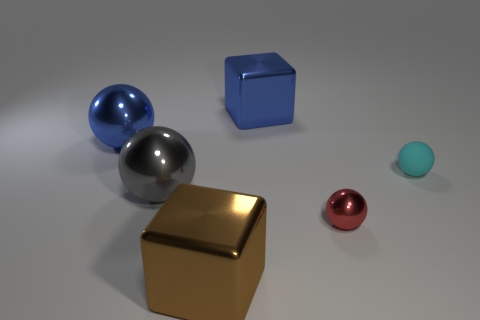Subtract all red balls. How many balls are left? 3 Subtract 1 balls. How many balls are left? 3 Subtract all gray spheres. How many spheres are left? 3 Add 1 red metal objects. How many objects exist? 7 Subtract 0 gray cubes. How many objects are left? 6 Subtract all blocks. How many objects are left? 4 Subtract all gray spheres. Subtract all red blocks. How many spheres are left? 3 Subtract all cyan balls. How many gray cubes are left? 0 Subtract all big rubber cubes. Subtract all large brown shiny things. How many objects are left? 5 Add 1 shiny things. How many shiny things are left? 6 